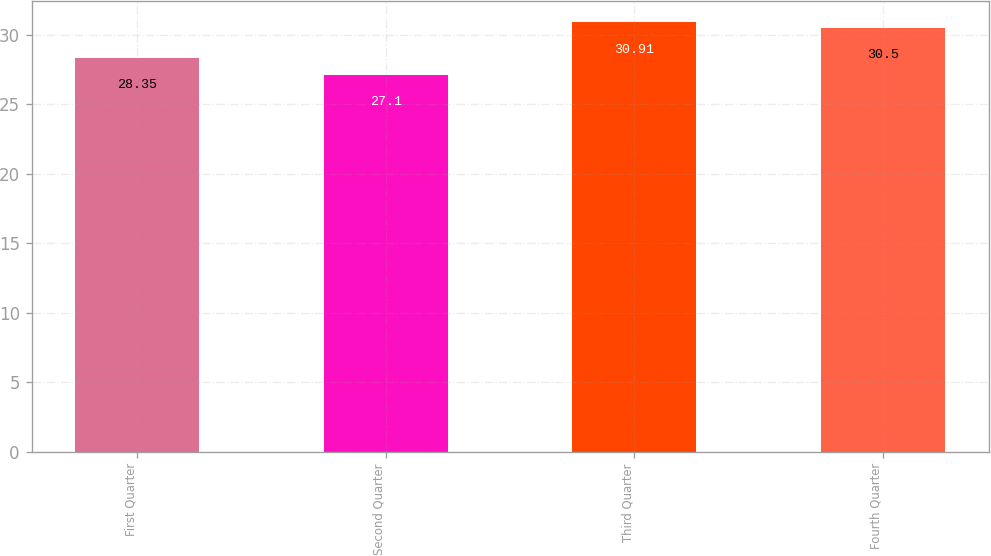<chart> <loc_0><loc_0><loc_500><loc_500><bar_chart><fcel>First Quarter<fcel>Second Quarter<fcel>Third Quarter<fcel>Fourth Quarter<nl><fcel>28.35<fcel>27.1<fcel>30.91<fcel>30.5<nl></chart> 